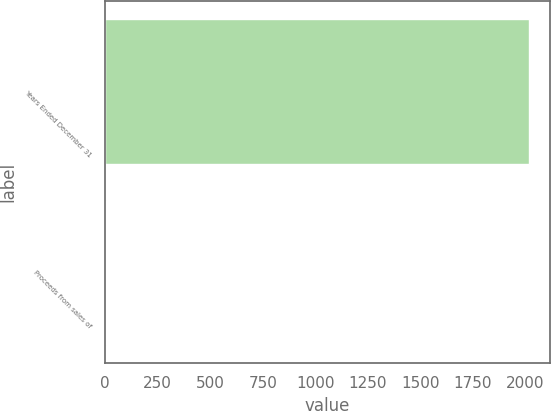Convert chart to OTSL. <chart><loc_0><loc_0><loc_500><loc_500><bar_chart><fcel>Years Ended December 31<fcel>Proceeds from sales of<nl><fcel>2015<fcel>3<nl></chart> 